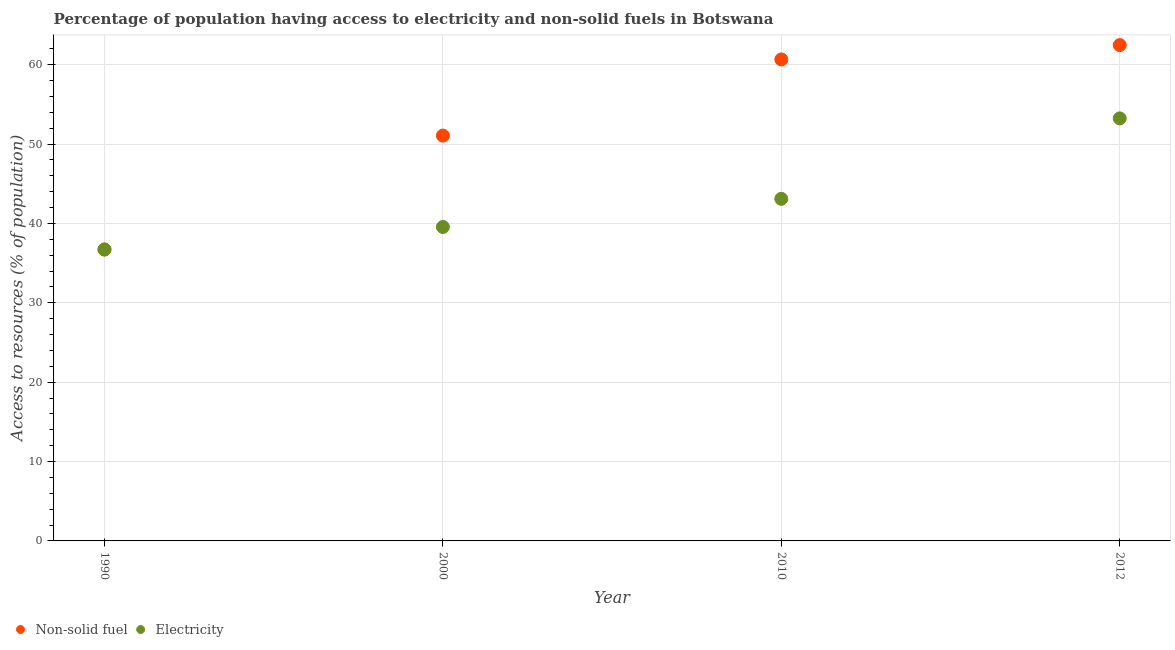What is the percentage of population having access to non-solid fuel in 2000?
Keep it short and to the point. 51.07. Across all years, what is the maximum percentage of population having access to electricity?
Keep it short and to the point. 53.24. Across all years, what is the minimum percentage of population having access to non-solid fuel?
Provide a succinct answer. 36.72. In which year was the percentage of population having access to electricity maximum?
Give a very brief answer. 2012. What is the total percentage of population having access to electricity in the graph?
Your response must be concise. 172.61. What is the difference between the percentage of population having access to non-solid fuel in 1990 and that in 2012?
Offer a terse response. -25.75. What is the difference between the percentage of population having access to electricity in 2010 and the percentage of population having access to non-solid fuel in 1990?
Keep it short and to the point. 6.38. What is the average percentage of population having access to non-solid fuel per year?
Offer a terse response. 52.73. In the year 2012, what is the difference between the percentage of population having access to electricity and percentage of population having access to non-solid fuel?
Offer a terse response. -9.23. What is the ratio of the percentage of population having access to non-solid fuel in 1990 to that in 2012?
Offer a terse response. 0.59. Is the difference between the percentage of population having access to non-solid fuel in 1990 and 2000 greater than the difference between the percentage of population having access to electricity in 1990 and 2000?
Your answer should be compact. No. What is the difference between the highest and the second highest percentage of population having access to electricity?
Provide a succinct answer. 10.14. What is the difference between the highest and the lowest percentage of population having access to electricity?
Offer a very short reply. 16.52. In how many years, is the percentage of population having access to electricity greater than the average percentage of population having access to electricity taken over all years?
Your answer should be compact. 1. Is the sum of the percentage of population having access to non-solid fuel in 1990 and 2010 greater than the maximum percentage of population having access to electricity across all years?
Ensure brevity in your answer.  Yes. Is the percentage of population having access to electricity strictly greater than the percentage of population having access to non-solid fuel over the years?
Make the answer very short. No. Is the percentage of population having access to non-solid fuel strictly less than the percentage of population having access to electricity over the years?
Make the answer very short. No. How many dotlines are there?
Give a very brief answer. 2. How many years are there in the graph?
Keep it short and to the point. 4. What is the difference between two consecutive major ticks on the Y-axis?
Keep it short and to the point. 10. Are the values on the major ticks of Y-axis written in scientific E-notation?
Keep it short and to the point. No. Where does the legend appear in the graph?
Ensure brevity in your answer.  Bottom left. What is the title of the graph?
Your response must be concise. Percentage of population having access to electricity and non-solid fuels in Botswana. Does "Female entrants" appear as one of the legend labels in the graph?
Your response must be concise. No. What is the label or title of the X-axis?
Provide a short and direct response. Year. What is the label or title of the Y-axis?
Provide a short and direct response. Access to resources (% of population). What is the Access to resources (% of population) in Non-solid fuel in 1990?
Your response must be concise. 36.72. What is the Access to resources (% of population) of Electricity in 1990?
Offer a terse response. 36.72. What is the Access to resources (% of population) of Non-solid fuel in 2000?
Provide a short and direct response. 51.07. What is the Access to resources (% of population) of Electricity in 2000?
Keep it short and to the point. 39.56. What is the Access to resources (% of population) in Non-solid fuel in 2010?
Make the answer very short. 60.67. What is the Access to resources (% of population) of Electricity in 2010?
Your response must be concise. 43.1. What is the Access to resources (% of population) of Non-solid fuel in 2012?
Provide a short and direct response. 62.47. What is the Access to resources (% of population) in Electricity in 2012?
Your answer should be very brief. 53.24. Across all years, what is the maximum Access to resources (% of population) of Non-solid fuel?
Your response must be concise. 62.47. Across all years, what is the maximum Access to resources (% of population) of Electricity?
Your answer should be compact. 53.24. Across all years, what is the minimum Access to resources (% of population) of Non-solid fuel?
Give a very brief answer. 36.72. Across all years, what is the minimum Access to resources (% of population) of Electricity?
Make the answer very short. 36.72. What is the total Access to resources (% of population) in Non-solid fuel in the graph?
Your response must be concise. 210.93. What is the total Access to resources (% of population) of Electricity in the graph?
Ensure brevity in your answer.  172.61. What is the difference between the Access to resources (% of population) in Non-solid fuel in 1990 and that in 2000?
Give a very brief answer. -14.35. What is the difference between the Access to resources (% of population) of Electricity in 1990 and that in 2000?
Your answer should be compact. -2.84. What is the difference between the Access to resources (% of population) of Non-solid fuel in 1990 and that in 2010?
Your answer should be compact. -23.95. What is the difference between the Access to resources (% of population) of Electricity in 1990 and that in 2010?
Make the answer very short. -6.38. What is the difference between the Access to resources (% of population) of Non-solid fuel in 1990 and that in 2012?
Your response must be concise. -25.75. What is the difference between the Access to resources (% of population) in Electricity in 1990 and that in 2012?
Make the answer very short. -16.52. What is the difference between the Access to resources (% of population) in Non-solid fuel in 2000 and that in 2010?
Your answer should be compact. -9.6. What is the difference between the Access to resources (% of population) of Electricity in 2000 and that in 2010?
Make the answer very short. -3.54. What is the difference between the Access to resources (% of population) in Non-solid fuel in 2000 and that in 2012?
Provide a succinct answer. -11.4. What is the difference between the Access to resources (% of population) of Electricity in 2000 and that in 2012?
Make the answer very short. -13.68. What is the difference between the Access to resources (% of population) in Non-solid fuel in 2010 and that in 2012?
Provide a short and direct response. -1.81. What is the difference between the Access to resources (% of population) of Electricity in 2010 and that in 2012?
Provide a succinct answer. -10.14. What is the difference between the Access to resources (% of population) in Non-solid fuel in 1990 and the Access to resources (% of population) in Electricity in 2000?
Your answer should be compact. -2.84. What is the difference between the Access to resources (% of population) of Non-solid fuel in 1990 and the Access to resources (% of population) of Electricity in 2010?
Offer a terse response. -6.38. What is the difference between the Access to resources (% of population) in Non-solid fuel in 1990 and the Access to resources (% of population) in Electricity in 2012?
Your answer should be compact. -16.52. What is the difference between the Access to resources (% of population) in Non-solid fuel in 2000 and the Access to resources (% of population) in Electricity in 2010?
Offer a very short reply. 7.97. What is the difference between the Access to resources (% of population) of Non-solid fuel in 2000 and the Access to resources (% of population) of Electricity in 2012?
Your answer should be very brief. -2.17. What is the difference between the Access to resources (% of population) in Non-solid fuel in 2010 and the Access to resources (% of population) in Electricity in 2012?
Offer a terse response. 7.43. What is the average Access to resources (% of population) of Non-solid fuel per year?
Provide a short and direct response. 52.73. What is the average Access to resources (% of population) of Electricity per year?
Provide a short and direct response. 43.15. In the year 1990, what is the difference between the Access to resources (% of population) in Non-solid fuel and Access to resources (% of population) in Electricity?
Give a very brief answer. 0. In the year 2000, what is the difference between the Access to resources (% of population) in Non-solid fuel and Access to resources (% of population) in Electricity?
Your answer should be very brief. 11.51. In the year 2010, what is the difference between the Access to resources (% of population) in Non-solid fuel and Access to resources (% of population) in Electricity?
Offer a very short reply. 17.57. In the year 2012, what is the difference between the Access to resources (% of population) of Non-solid fuel and Access to resources (% of population) of Electricity?
Your answer should be compact. 9.23. What is the ratio of the Access to resources (% of population) in Non-solid fuel in 1990 to that in 2000?
Your response must be concise. 0.72. What is the ratio of the Access to resources (% of population) of Electricity in 1990 to that in 2000?
Your answer should be very brief. 0.93. What is the ratio of the Access to resources (% of population) in Non-solid fuel in 1990 to that in 2010?
Keep it short and to the point. 0.61. What is the ratio of the Access to resources (% of population) of Electricity in 1990 to that in 2010?
Provide a succinct answer. 0.85. What is the ratio of the Access to resources (% of population) in Non-solid fuel in 1990 to that in 2012?
Make the answer very short. 0.59. What is the ratio of the Access to resources (% of population) of Electricity in 1990 to that in 2012?
Your answer should be very brief. 0.69. What is the ratio of the Access to resources (% of population) of Non-solid fuel in 2000 to that in 2010?
Your response must be concise. 0.84. What is the ratio of the Access to resources (% of population) in Electricity in 2000 to that in 2010?
Your answer should be very brief. 0.92. What is the ratio of the Access to resources (% of population) in Non-solid fuel in 2000 to that in 2012?
Keep it short and to the point. 0.82. What is the ratio of the Access to resources (% of population) in Electricity in 2000 to that in 2012?
Ensure brevity in your answer.  0.74. What is the ratio of the Access to resources (% of population) of Non-solid fuel in 2010 to that in 2012?
Keep it short and to the point. 0.97. What is the ratio of the Access to resources (% of population) in Electricity in 2010 to that in 2012?
Provide a succinct answer. 0.81. What is the difference between the highest and the second highest Access to resources (% of population) in Non-solid fuel?
Offer a terse response. 1.81. What is the difference between the highest and the second highest Access to resources (% of population) of Electricity?
Your answer should be compact. 10.14. What is the difference between the highest and the lowest Access to resources (% of population) in Non-solid fuel?
Offer a terse response. 25.75. What is the difference between the highest and the lowest Access to resources (% of population) of Electricity?
Give a very brief answer. 16.52. 